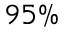<formula> <loc_0><loc_0><loc_500><loc_500>9 5 \%</formula> 